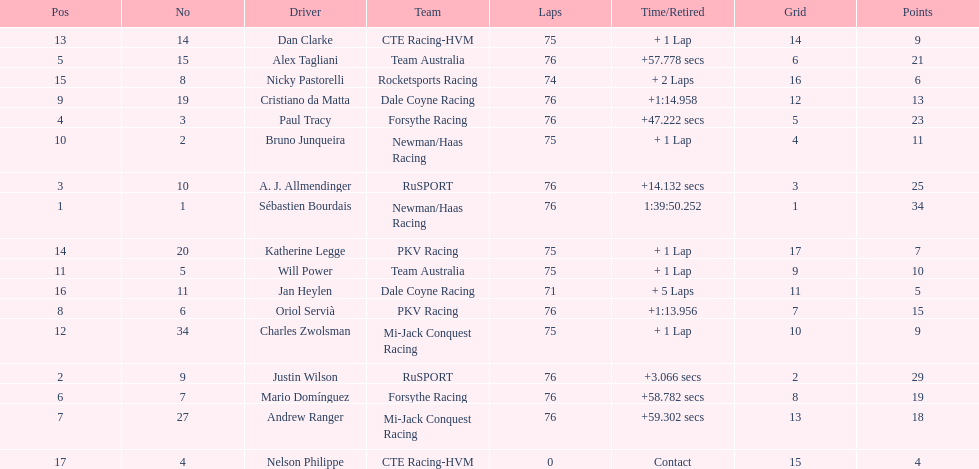What was the total points that canada earned together? 62. 